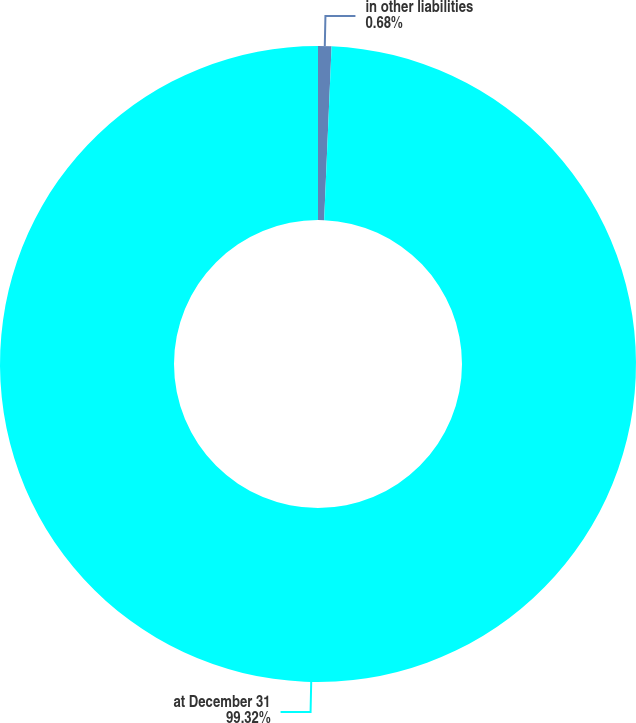Convert chart to OTSL. <chart><loc_0><loc_0><loc_500><loc_500><pie_chart><fcel>in other liabilities<fcel>at December 31<nl><fcel>0.68%<fcel>99.32%<nl></chart> 